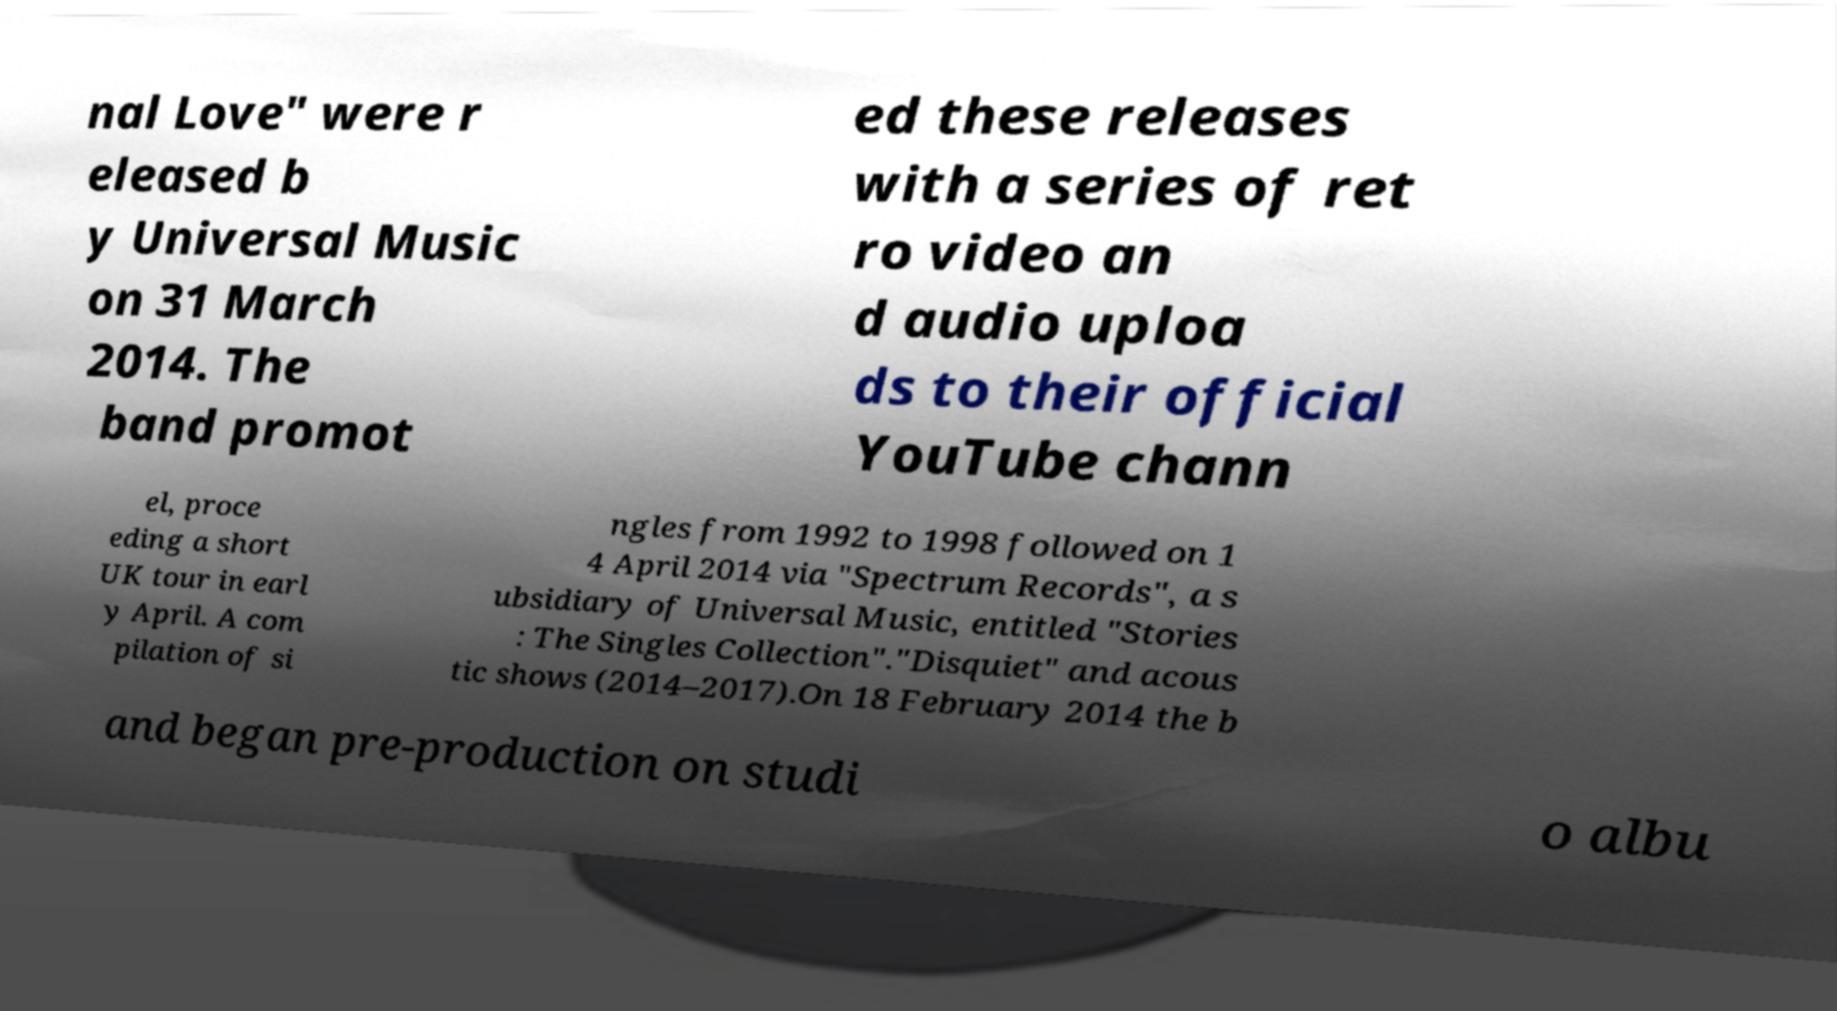For documentation purposes, I need the text within this image transcribed. Could you provide that? nal Love" were r eleased b y Universal Music on 31 March 2014. The band promot ed these releases with a series of ret ro video an d audio uploa ds to their official YouTube chann el, proce eding a short UK tour in earl y April. A com pilation of si ngles from 1992 to 1998 followed on 1 4 April 2014 via "Spectrum Records", a s ubsidiary of Universal Music, entitled "Stories : The Singles Collection"."Disquiet" and acous tic shows (2014–2017).On 18 February 2014 the b and began pre-production on studi o albu 